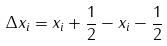<formula> <loc_0><loc_0><loc_500><loc_500>\Delta x _ { i } = x _ { i } + \frac { 1 } { 2 } - x _ { i } - \frac { 1 } { 2 }</formula> 